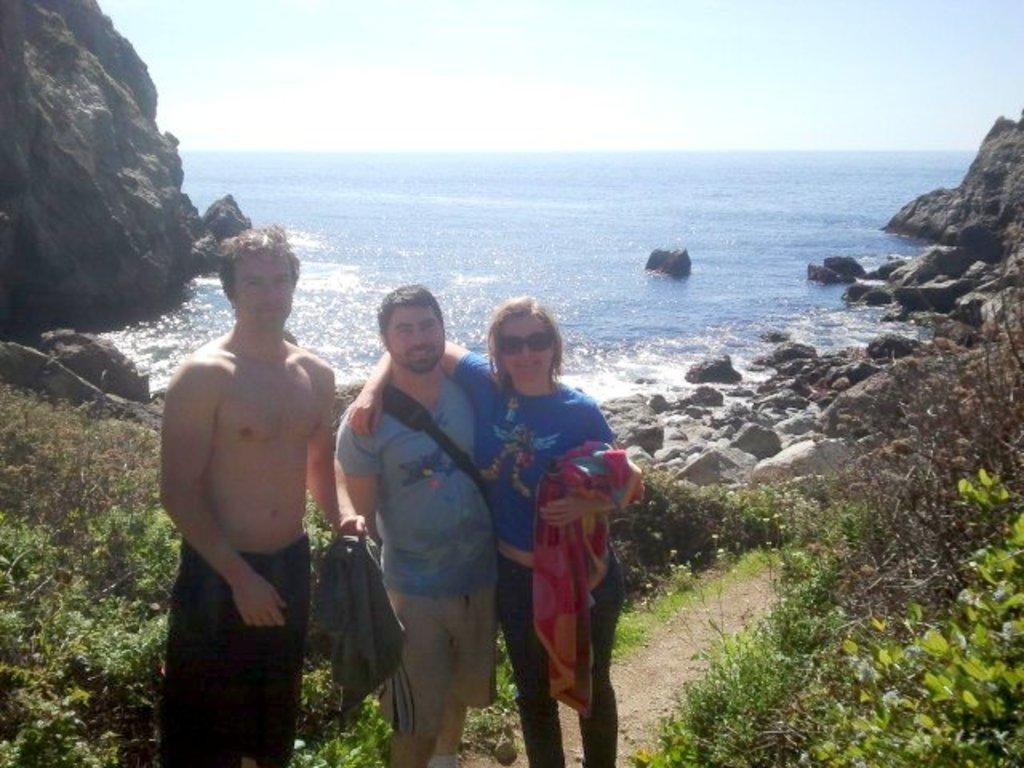In one or two sentences, can you explain what this image depicts? In this picture we can see two men and a woman are standing and smiling, this woman is holding a cloth, at the bottom there are some plants, we can see water and rocks in the middle, on the left side there is a hill, we can see the sky at the top of the picture. 